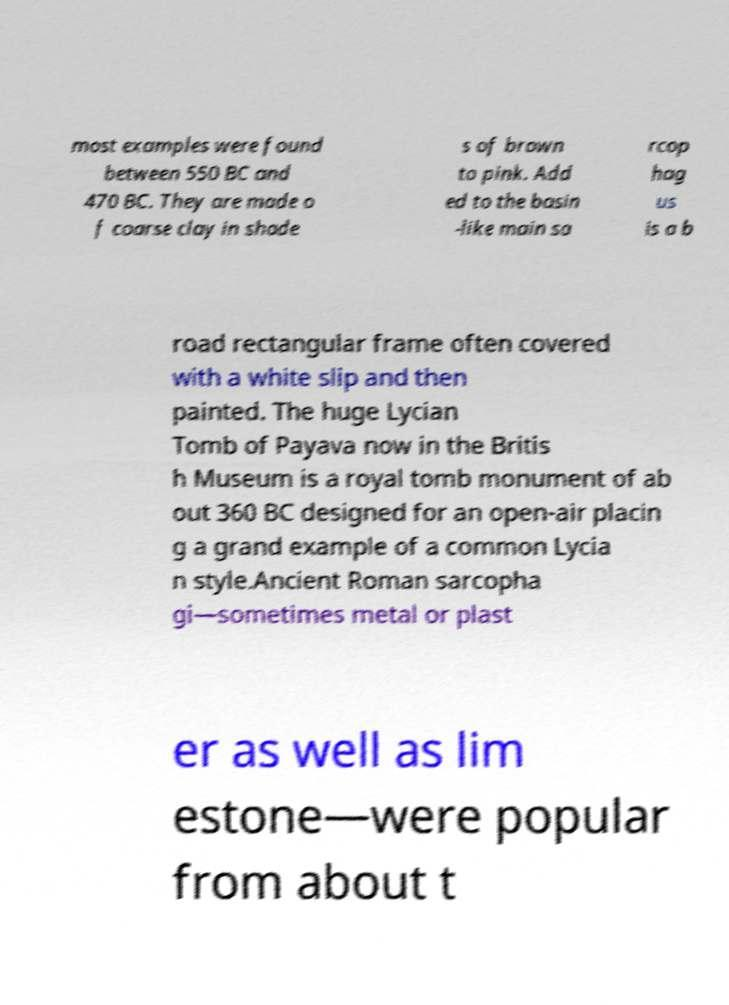Please read and relay the text visible in this image. What does it say? most examples were found between 550 BC and 470 BC. They are made o f coarse clay in shade s of brown to pink. Add ed to the basin -like main sa rcop hag us is a b road rectangular frame often covered with a white slip and then painted. The huge Lycian Tomb of Payava now in the Britis h Museum is a royal tomb monument of ab out 360 BC designed for an open-air placin g a grand example of a common Lycia n style.Ancient Roman sarcopha gi—sometimes metal or plast er as well as lim estone—were popular from about t 